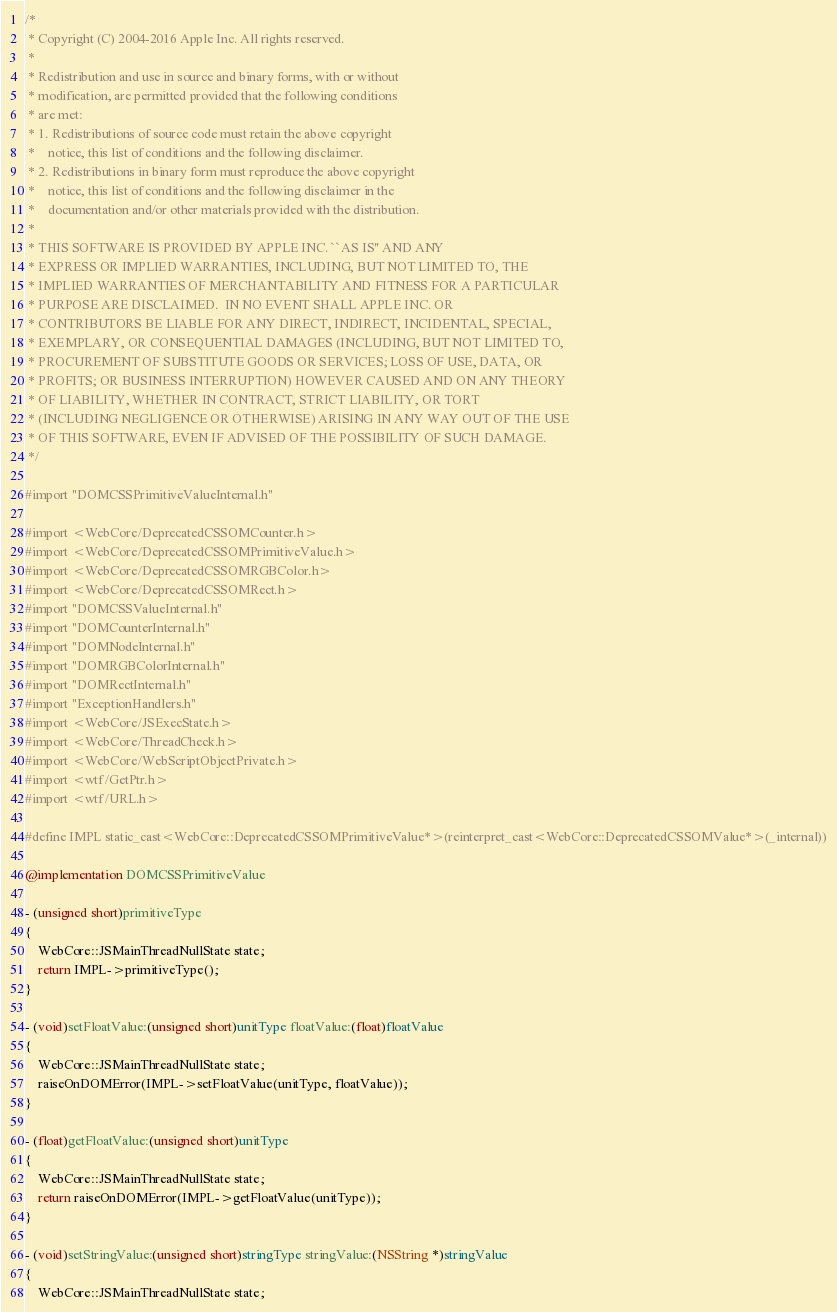<code> <loc_0><loc_0><loc_500><loc_500><_ObjectiveC_>/*
 * Copyright (C) 2004-2016 Apple Inc. All rights reserved.
 *
 * Redistribution and use in source and binary forms, with or without
 * modification, are permitted provided that the following conditions
 * are met:
 * 1. Redistributions of source code must retain the above copyright
 *    notice, this list of conditions and the following disclaimer.
 * 2. Redistributions in binary form must reproduce the above copyright
 *    notice, this list of conditions and the following disclaimer in the
 *    documentation and/or other materials provided with the distribution.
 *
 * THIS SOFTWARE IS PROVIDED BY APPLE INC. ``AS IS'' AND ANY
 * EXPRESS OR IMPLIED WARRANTIES, INCLUDING, BUT NOT LIMITED TO, THE
 * IMPLIED WARRANTIES OF MERCHANTABILITY AND FITNESS FOR A PARTICULAR
 * PURPOSE ARE DISCLAIMED.  IN NO EVENT SHALL APPLE INC. OR
 * CONTRIBUTORS BE LIABLE FOR ANY DIRECT, INDIRECT, INCIDENTAL, SPECIAL,
 * EXEMPLARY, OR CONSEQUENTIAL DAMAGES (INCLUDING, BUT NOT LIMITED TO,
 * PROCUREMENT OF SUBSTITUTE GOODS OR SERVICES; LOSS OF USE, DATA, OR
 * PROFITS; OR BUSINESS INTERRUPTION) HOWEVER CAUSED AND ON ANY THEORY
 * OF LIABILITY, WHETHER IN CONTRACT, STRICT LIABILITY, OR TORT
 * (INCLUDING NEGLIGENCE OR OTHERWISE) ARISING IN ANY WAY OUT OF THE USE
 * OF THIS SOFTWARE, EVEN IF ADVISED OF THE POSSIBILITY OF SUCH DAMAGE.
 */

#import "DOMCSSPrimitiveValueInternal.h"

#import <WebCore/DeprecatedCSSOMCounter.h>
#import <WebCore/DeprecatedCSSOMPrimitiveValue.h>
#import <WebCore/DeprecatedCSSOMRGBColor.h>
#import <WebCore/DeprecatedCSSOMRect.h>
#import "DOMCSSValueInternal.h"
#import "DOMCounterInternal.h"
#import "DOMNodeInternal.h"
#import "DOMRGBColorInternal.h"
#import "DOMRectInternal.h"
#import "ExceptionHandlers.h"
#import <WebCore/JSExecState.h>
#import <WebCore/ThreadCheck.h>
#import <WebCore/WebScriptObjectPrivate.h>
#import <wtf/GetPtr.h>
#import <wtf/URL.h>

#define IMPL static_cast<WebCore::DeprecatedCSSOMPrimitiveValue*>(reinterpret_cast<WebCore::DeprecatedCSSOMValue*>(_internal))

@implementation DOMCSSPrimitiveValue

- (unsigned short)primitiveType
{
    WebCore::JSMainThreadNullState state;
    return IMPL->primitiveType();
}

- (void)setFloatValue:(unsigned short)unitType floatValue:(float)floatValue
{
    WebCore::JSMainThreadNullState state;
    raiseOnDOMError(IMPL->setFloatValue(unitType, floatValue));
}

- (float)getFloatValue:(unsigned short)unitType
{
    WebCore::JSMainThreadNullState state;
    return raiseOnDOMError(IMPL->getFloatValue(unitType));
}

- (void)setStringValue:(unsigned short)stringType stringValue:(NSString *)stringValue
{
    WebCore::JSMainThreadNullState state;</code> 